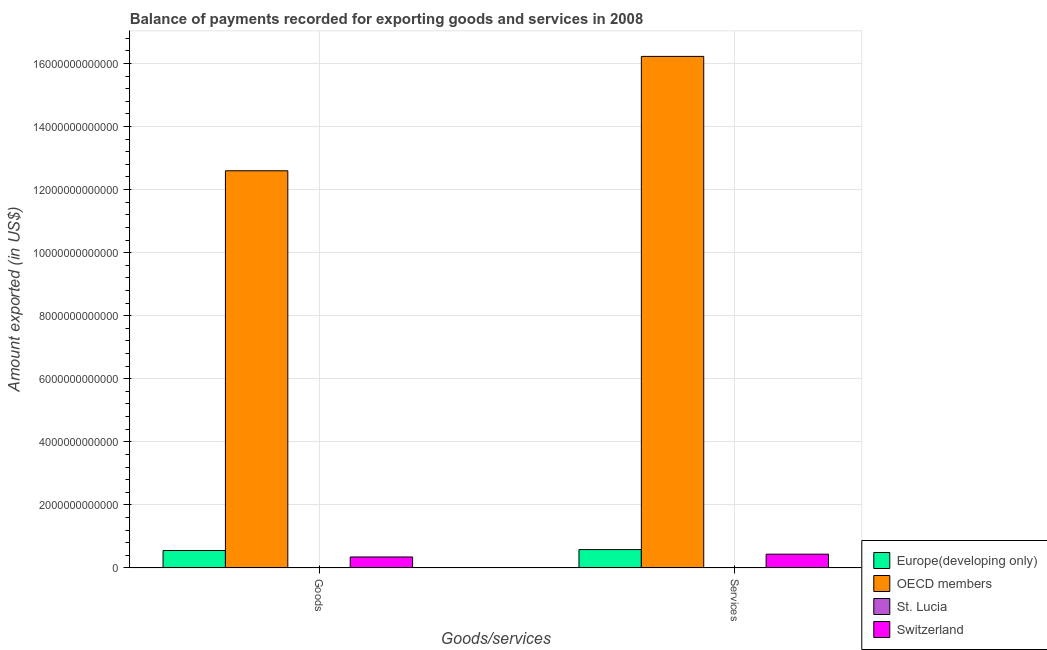How many different coloured bars are there?
Provide a succinct answer. 4. What is the label of the 1st group of bars from the left?
Provide a succinct answer. Goods. What is the amount of services exported in OECD members?
Offer a very short reply. 1.62e+13. Across all countries, what is the maximum amount of services exported?
Your response must be concise. 1.62e+13. Across all countries, what is the minimum amount of goods exported?
Ensure brevity in your answer.  5.36e+08. In which country was the amount of services exported maximum?
Make the answer very short. OECD members. In which country was the amount of services exported minimum?
Your answer should be compact. St. Lucia. What is the total amount of goods exported in the graph?
Give a very brief answer. 1.35e+13. What is the difference between the amount of services exported in St. Lucia and that in Europe(developing only)?
Offer a terse response. -5.82e+11. What is the difference between the amount of services exported in Switzerland and the amount of goods exported in St. Lucia?
Make the answer very short. 4.36e+11. What is the average amount of services exported per country?
Ensure brevity in your answer.  4.31e+12. What is the difference between the amount of goods exported and amount of services exported in OECD members?
Provide a short and direct response. -3.63e+12. What is the ratio of the amount of goods exported in Switzerland to that in St. Lucia?
Offer a terse response. 649.11. Is the amount of services exported in Europe(developing only) less than that in OECD members?
Keep it short and to the point. Yes. What does the 1st bar from the left in Services represents?
Ensure brevity in your answer.  Europe(developing only). What does the 4th bar from the right in Services represents?
Ensure brevity in your answer.  Europe(developing only). Are all the bars in the graph horizontal?
Give a very brief answer. No. What is the difference between two consecutive major ticks on the Y-axis?
Make the answer very short. 2.00e+12. Are the values on the major ticks of Y-axis written in scientific E-notation?
Offer a very short reply. No. Does the graph contain any zero values?
Your answer should be very brief. No. Where does the legend appear in the graph?
Ensure brevity in your answer.  Bottom right. How many legend labels are there?
Your answer should be compact. 4. What is the title of the graph?
Make the answer very short. Balance of payments recorded for exporting goods and services in 2008. Does "Yemen, Rep." appear as one of the legend labels in the graph?
Provide a short and direct response. No. What is the label or title of the X-axis?
Your response must be concise. Goods/services. What is the label or title of the Y-axis?
Give a very brief answer. Amount exported (in US$). What is the Amount exported (in US$) of Europe(developing only) in Goods?
Give a very brief answer. 5.53e+11. What is the Amount exported (in US$) in OECD members in Goods?
Make the answer very short. 1.26e+13. What is the Amount exported (in US$) in St. Lucia in Goods?
Your response must be concise. 5.36e+08. What is the Amount exported (in US$) in Switzerland in Goods?
Offer a very short reply. 3.48e+11. What is the Amount exported (in US$) of Europe(developing only) in Services?
Make the answer very short. 5.82e+11. What is the Amount exported (in US$) of OECD members in Services?
Provide a short and direct response. 1.62e+13. What is the Amount exported (in US$) of St. Lucia in Services?
Offer a terse response. 5.44e+08. What is the Amount exported (in US$) in Switzerland in Services?
Your response must be concise. 4.37e+11. Across all Goods/services, what is the maximum Amount exported (in US$) in Europe(developing only)?
Keep it short and to the point. 5.82e+11. Across all Goods/services, what is the maximum Amount exported (in US$) of OECD members?
Provide a succinct answer. 1.62e+13. Across all Goods/services, what is the maximum Amount exported (in US$) in St. Lucia?
Provide a succinct answer. 5.44e+08. Across all Goods/services, what is the maximum Amount exported (in US$) in Switzerland?
Your response must be concise. 4.37e+11. Across all Goods/services, what is the minimum Amount exported (in US$) in Europe(developing only)?
Your answer should be very brief. 5.53e+11. Across all Goods/services, what is the minimum Amount exported (in US$) of OECD members?
Make the answer very short. 1.26e+13. Across all Goods/services, what is the minimum Amount exported (in US$) of St. Lucia?
Offer a very short reply. 5.36e+08. Across all Goods/services, what is the minimum Amount exported (in US$) in Switzerland?
Offer a terse response. 3.48e+11. What is the total Amount exported (in US$) of Europe(developing only) in the graph?
Make the answer very short. 1.14e+12. What is the total Amount exported (in US$) in OECD members in the graph?
Keep it short and to the point. 2.88e+13. What is the total Amount exported (in US$) in St. Lucia in the graph?
Ensure brevity in your answer.  1.08e+09. What is the total Amount exported (in US$) in Switzerland in the graph?
Give a very brief answer. 7.85e+11. What is the difference between the Amount exported (in US$) of Europe(developing only) in Goods and that in Services?
Offer a very short reply. -2.91e+1. What is the difference between the Amount exported (in US$) in OECD members in Goods and that in Services?
Provide a short and direct response. -3.63e+12. What is the difference between the Amount exported (in US$) of St. Lucia in Goods and that in Services?
Your answer should be compact. -8.23e+06. What is the difference between the Amount exported (in US$) of Switzerland in Goods and that in Services?
Offer a very short reply. -8.89e+1. What is the difference between the Amount exported (in US$) in Europe(developing only) in Goods and the Amount exported (in US$) in OECD members in Services?
Give a very brief answer. -1.57e+13. What is the difference between the Amount exported (in US$) of Europe(developing only) in Goods and the Amount exported (in US$) of St. Lucia in Services?
Offer a terse response. 5.53e+11. What is the difference between the Amount exported (in US$) of Europe(developing only) in Goods and the Amount exported (in US$) of Switzerland in Services?
Keep it short and to the point. 1.16e+11. What is the difference between the Amount exported (in US$) of OECD members in Goods and the Amount exported (in US$) of St. Lucia in Services?
Offer a very short reply. 1.26e+13. What is the difference between the Amount exported (in US$) of OECD members in Goods and the Amount exported (in US$) of Switzerland in Services?
Ensure brevity in your answer.  1.22e+13. What is the difference between the Amount exported (in US$) of St. Lucia in Goods and the Amount exported (in US$) of Switzerland in Services?
Provide a succinct answer. -4.36e+11. What is the average Amount exported (in US$) of Europe(developing only) per Goods/services?
Provide a short and direct response. 5.68e+11. What is the average Amount exported (in US$) of OECD members per Goods/services?
Offer a very short reply. 1.44e+13. What is the average Amount exported (in US$) of St. Lucia per Goods/services?
Provide a short and direct response. 5.40e+08. What is the average Amount exported (in US$) of Switzerland per Goods/services?
Keep it short and to the point. 3.92e+11. What is the difference between the Amount exported (in US$) in Europe(developing only) and Amount exported (in US$) in OECD members in Goods?
Provide a short and direct response. -1.20e+13. What is the difference between the Amount exported (in US$) of Europe(developing only) and Amount exported (in US$) of St. Lucia in Goods?
Provide a short and direct response. 5.53e+11. What is the difference between the Amount exported (in US$) of Europe(developing only) and Amount exported (in US$) of Switzerland in Goods?
Offer a very short reply. 2.05e+11. What is the difference between the Amount exported (in US$) of OECD members and Amount exported (in US$) of St. Lucia in Goods?
Make the answer very short. 1.26e+13. What is the difference between the Amount exported (in US$) in OECD members and Amount exported (in US$) in Switzerland in Goods?
Offer a terse response. 1.22e+13. What is the difference between the Amount exported (in US$) in St. Lucia and Amount exported (in US$) in Switzerland in Goods?
Keep it short and to the point. -3.47e+11. What is the difference between the Amount exported (in US$) of Europe(developing only) and Amount exported (in US$) of OECD members in Services?
Make the answer very short. -1.56e+13. What is the difference between the Amount exported (in US$) of Europe(developing only) and Amount exported (in US$) of St. Lucia in Services?
Keep it short and to the point. 5.82e+11. What is the difference between the Amount exported (in US$) in Europe(developing only) and Amount exported (in US$) in Switzerland in Services?
Your answer should be very brief. 1.46e+11. What is the difference between the Amount exported (in US$) of OECD members and Amount exported (in US$) of St. Lucia in Services?
Offer a very short reply. 1.62e+13. What is the difference between the Amount exported (in US$) of OECD members and Amount exported (in US$) of Switzerland in Services?
Provide a succinct answer. 1.58e+13. What is the difference between the Amount exported (in US$) in St. Lucia and Amount exported (in US$) in Switzerland in Services?
Provide a short and direct response. -4.36e+11. What is the ratio of the Amount exported (in US$) in Europe(developing only) in Goods to that in Services?
Keep it short and to the point. 0.95. What is the ratio of the Amount exported (in US$) in OECD members in Goods to that in Services?
Offer a terse response. 0.78. What is the ratio of the Amount exported (in US$) in St. Lucia in Goods to that in Services?
Offer a very short reply. 0.98. What is the ratio of the Amount exported (in US$) of Switzerland in Goods to that in Services?
Keep it short and to the point. 0.8. What is the difference between the highest and the second highest Amount exported (in US$) in Europe(developing only)?
Make the answer very short. 2.91e+1. What is the difference between the highest and the second highest Amount exported (in US$) of OECD members?
Provide a succinct answer. 3.63e+12. What is the difference between the highest and the second highest Amount exported (in US$) of St. Lucia?
Keep it short and to the point. 8.23e+06. What is the difference between the highest and the second highest Amount exported (in US$) of Switzerland?
Make the answer very short. 8.89e+1. What is the difference between the highest and the lowest Amount exported (in US$) of Europe(developing only)?
Provide a short and direct response. 2.91e+1. What is the difference between the highest and the lowest Amount exported (in US$) of OECD members?
Give a very brief answer. 3.63e+12. What is the difference between the highest and the lowest Amount exported (in US$) of St. Lucia?
Ensure brevity in your answer.  8.23e+06. What is the difference between the highest and the lowest Amount exported (in US$) of Switzerland?
Offer a terse response. 8.89e+1. 